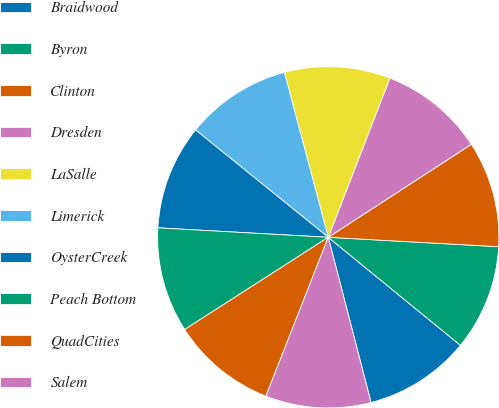Convert chart to OTSL. <chart><loc_0><loc_0><loc_500><loc_500><pie_chart><fcel>Braidwood<fcel>Byron<fcel>Clinton<fcel>Dresden<fcel>LaSalle<fcel>Limerick<fcel>OysterCreek<fcel>Peach Bottom<fcel>QuadCities<fcel>Salem<nl><fcel>10.06%<fcel>10.03%<fcel>10.05%<fcel>9.95%<fcel>10.02%<fcel>10.04%<fcel>9.94%<fcel>9.97%<fcel>9.96%<fcel>9.99%<nl></chart> 